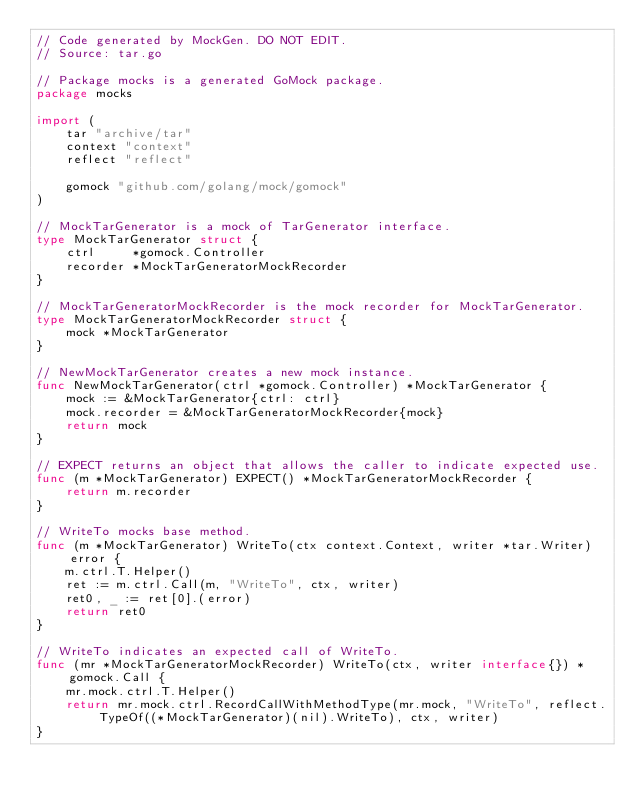Convert code to text. <code><loc_0><loc_0><loc_500><loc_500><_Go_>// Code generated by MockGen. DO NOT EDIT.
// Source: tar.go

// Package mocks is a generated GoMock package.
package mocks

import (
	tar "archive/tar"
	context "context"
	reflect "reflect"

	gomock "github.com/golang/mock/gomock"
)

// MockTarGenerator is a mock of TarGenerator interface.
type MockTarGenerator struct {
	ctrl     *gomock.Controller
	recorder *MockTarGeneratorMockRecorder
}

// MockTarGeneratorMockRecorder is the mock recorder for MockTarGenerator.
type MockTarGeneratorMockRecorder struct {
	mock *MockTarGenerator
}

// NewMockTarGenerator creates a new mock instance.
func NewMockTarGenerator(ctrl *gomock.Controller) *MockTarGenerator {
	mock := &MockTarGenerator{ctrl: ctrl}
	mock.recorder = &MockTarGeneratorMockRecorder{mock}
	return mock
}

// EXPECT returns an object that allows the caller to indicate expected use.
func (m *MockTarGenerator) EXPECT() *MockTarGeneratorMockRecorder {
	return m.recorder
}

// WriteTo mocks base method.
func (m *MockTarGenerator) WriteTo(ctx context.Context, writer *tar.Writer) error {
	m.ctrl.T.Helper()
	ret := m.ctrl.Call(m, "WriteTo", ctx, writer)
	ret0, _ := ret[0].(error)
	return ret0
}

// WriteTo indicates an expected call of WriteTo.
func (mr *MockTarGeneratorMockRecorder) WriteTo(ctx, writer interface{}) *gomock.Call {
	mr.mock.ctrl.T.Helper()
	return mr.mock.ctrl.RecordCallWithMethodType(mr.mock, "WriteTo", reflect.TypeOf((*MockTarGenerator)(nil).WriteTo), ctx, writer)
}
</code> 